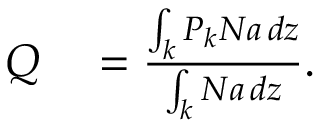Convert formula to latex. <formula><loc_0><loc_0><loc_500><loc_500>\begin{array} { r l } { Q } & = \frac { \int _ { k } P _ { k } N a \, d z } { \int _ { k } N a \, d z } . } \end{array}</formula> 